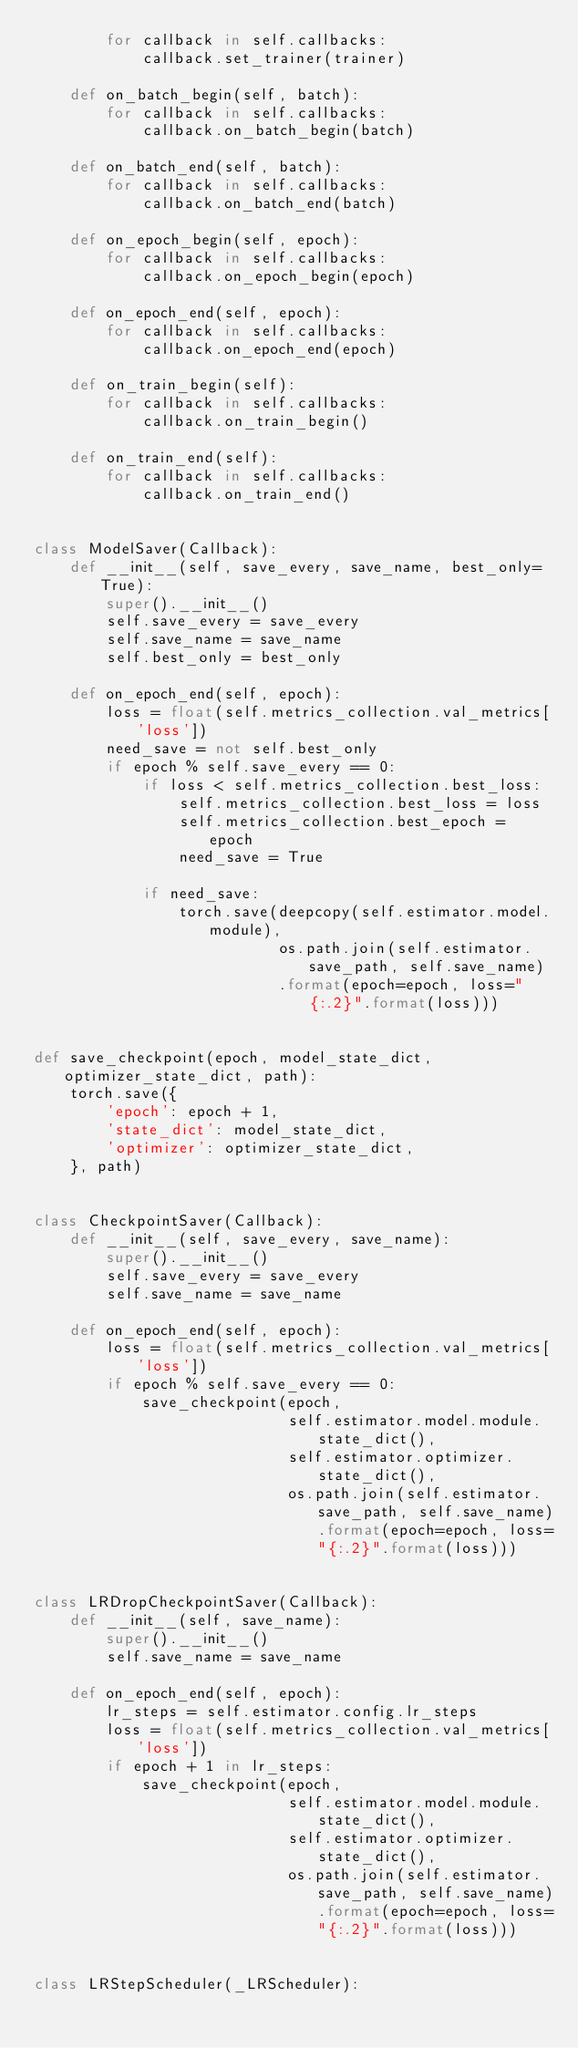Convert code to text. <code><loc_0><loc_0><loc_500><loc_500><_Python_>        for callback in self.callbacks:
            callback.set_trainer(trainer)

    def on_batch_begin(self, batch):
        for callback in self.callbacks:
            callback.on_batch_begin(batch)

    def on_batch_end(self, batch):
        for callback in self.callbacks:
            callback.on_batch_end(batch)

    def on_epoch_begin(self, epoch):
        for callback in self.callbacks:
            callback.on_epoch_begin(epoch)

    def on_epoch_end(self, epoch):
        for callback in self.callbacks:
            callback.on_epoch_end(epoch)

    def on_train_begin(self):
        for callback in self.callbacks:
            callback.on_train_begin()

    def on_train_end(self):
        for callback in self.callbacks:
            callback.on_train_end()


class ModelSaver(Callback):
    def __init__(self, save_every, save_name, best_only=True):
        super().__init__()
        self.save_every = save_every
        self.save_name = save_name
        self.best_only = best_only

    def on_epoch_end(self, epoch):
        loss = float(self.metrics_collection.val_metrics['loss'])
        need_save = not self.best_only
        if epoch % self.save_every == 0:
            if loss < self.metrics_collection.best_loss:
                self.metrics_collection.best_loss = loss
                self.metrics_collection.best_epoch = epoch
                need_save = True

            if need_save:
                torch.save(deepcopy(self.estimator.model.module),
                           os.path.join(self.estimator.save_path, self.save_name)
                           .format(epoch=epoch, loss="{:.2}".format(loss)))


def save_checkpoint(epoch, model_state_dict, optimizer_state_dict, path):
    torch.save({
        'epoch': epoch + 1,
        'state_dict': model_state_dict,
        'optimizer': optimizer_state_dict,
    }, path)


class CheckpointSaver(Callback):
    def __init__(self, save_every, save_name):
        super().__init__()
        self.save_every = save_every
        self.save_name = save_name

    def on_epoch_end(self, epoch):
        loss = float(self.metrics_collection.val_metrics['loss'])
        if epoch % self.save_every == 0:
            save_checkpoint(epoch,
                            self.estimator.model.module.state_dict(),
                            self.estimator.optimizer.state_dict(),
                            os.path.join(self.estimator.save_path, self.save_name).format(epoch=epoch, loss="{:.2}".format(loss)))


class LRDropCheckpointSaver(Callback):
    def __init__(self, save_name):
        super().__init__()
        self.save_name = save_name

    def on_epoch_end(self, epoch):
        lr_steps = self.estimator.config.lr_steps
        loss = float(self.metrics_collection.val_metrics['loss'])
        if epoch + 1 in lr_steps:
            save_checkpoint(epoch,
                            self.estimator.model.module.state_dict(),
                            self.estimator.optimizer.state_dict(),
                            os.path.join(self.estimator.save_path, self.save_name).format(epoch=epoch, loss="{:.2}".format(loss)))


class LRStepScheduler(_LRScheduler):</code> 